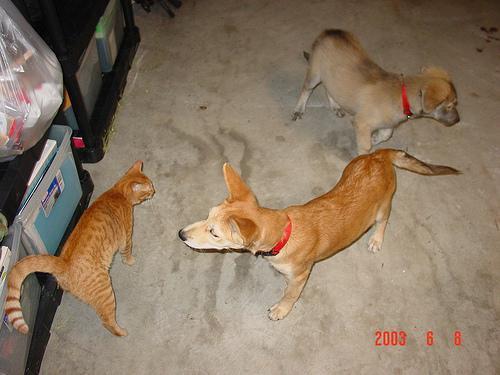How many animals are there?
Give a very brief answer. 3. 